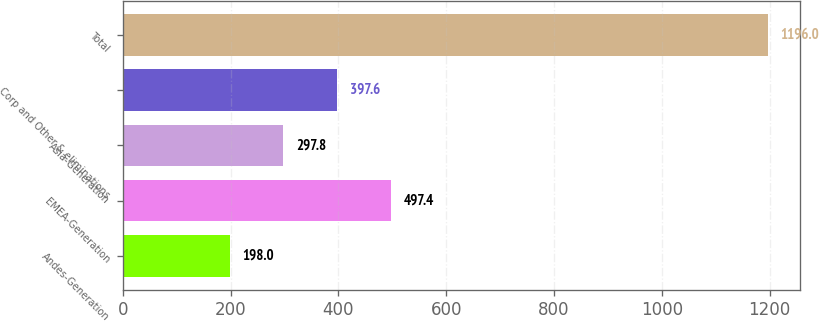Convert chart to OTSL. <chart><loc_0><loc_0><loc_500><loc_500><bar_chart><fcel>Andes-Generation<fcel>EMEA-Generation<fcel>Asia-Generation<fcel>Corp and Other & eliminations<fcel>Total<nl><fcel>198<fcel>497.4<fcel>297.8<fcel>397.6<fcel>1196<nl></chart> 